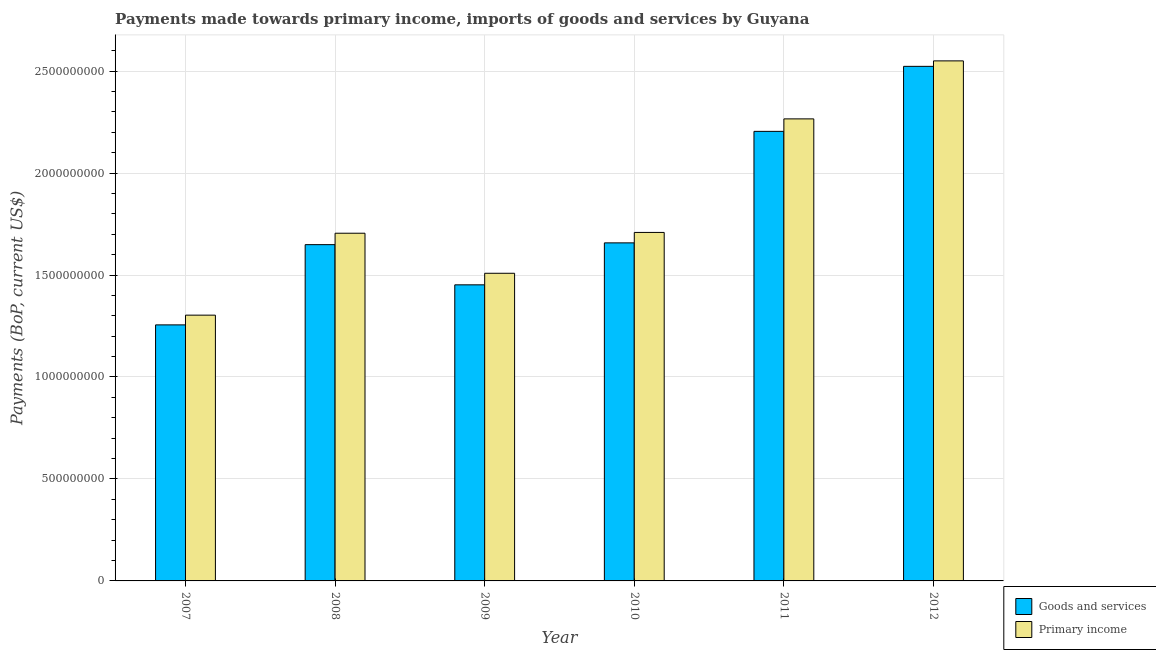How many different coloured bars are there?
Offer a terse response. 2. How many groups of bars are there?
Offer a terse response. 6. Are the number of bars per tick equal to the number of legend labels?
Give a very brief answer. Yes. How many bars are there on the 4th tick from the left?
Provide a succinct answer. 2. What is the label of the 1st group of bars from the left?
Your answer should be very brief. 2007. What is the payments made towards primary income in 2010?
Provide a short and direct response. 1.71e+09. Across all years, what is the maximum payments made towards goods and services?
Offer a very short reply. 2.52e+09. Across all years, what is the minimum payments made towards primary income?
Make the answer very short. 1.30e+09. In which year was the payments made towards goods and services maximum?
Make the answer very short. 2012. In which year was the payments made towards primary income minimum?
Offer a very short reply. 2007. What is the total payments made towards goods and services in the graph?
Provide a short and direct response. 1.07e+1. What is the difference between the payments made towards goods and services in 2007 and that in 2008?
Offer a terse response. -3.93e+08. What is the difference between the payments made towards primary income in 2012 and the payments made towards goods and services in 2010?
Provide a short and direct response. 8.41e+08. What is the average payments made towards goods and services per year?
Provide a short and direct response. 1.79e+09. What is the ratio of the payments made towards goods and services in 2008 to that in 2011?
Your response must be concise. 0.75. Is the difference between the payments made towards primary income in 2007 and 2010 greater than the difference between the payments made towards goods and services in 2007 and 2010?
Provide a short and direct response. No. What is the difference between the highest and the second highest payments made towards primary income?
Your response must be concise. 2.84e+08. What is the difference between the highest and the lowest payments made towards primary income?
Offer a very short reply. 1.25e+09. In how many years, is the payments made towards primary income greater than the average payments made towards primary income taken over all years?
Your answer should be very brief. 2. What does the 2nd bar from the left in 2011 represents?
Provide a short and direct response. Primary income. What does the 2nd bar from the right in 2009 represents?
Ensure brevity in your answer.  Goods and services. How many bars are there?
Your answer should be very brief. 12. Are all the bars in the graph horizontal?
Make the answer very short. No. How many years are there in the graph?
Offer a terse response. 6. Are the values on the major ticks of Y-axis written in scientific E-notation?
Ensure brevity in your answer.  No. How many legend labels are there?
Provide a short and direct response. 2. What is the title of the graph?
Provide a short and direct response. Payments made towards primary income, imports of goods and services by Guyana. Does "Primary completion rate" appear as one of the legend labels in the graph?
Keep it short and to the point. No. What is the label or title of the Y-axis?
Your response must be concise. Payments (BoP, current US$). What is the Payments (BoP, current US$) of Goods and services in 2007?
Offer a very short reply. 1.26e+09. What is the Payments (BoP, current US$) of Primary income in 2007?
Provide a succinct answer. 1.30e+09. What is the Payments (BoP, current US$) of Goods and services in 2008?
Keep it short and to the point. 1.65e+09. What is the Payments (BoP, current US$) in Primary income in 2008?
Ensure brevity in your answer.  1.70e+09. What is the Payments (BoP, current US$) of Goods and services in 2009?
Provide a succinct answer. 1.45e+09. What is the Payments (BoP, current US$) in Primary income in 2009?
Offer a very short reply. 1.51e+09. What is the Payments (BoP, current US$) of Goods and services in 2010?
Offer a terse response. 1.66e+09. What is the Payments (BoP, current US$) in Primary income in 2010?
Keep it short and to the point. 1.71e+09. What is the Payments (BoP, current US$) of Goods and services in 2011?
Your answer should be compact. 2.20e+09. What is the Payments (BoP, current US$) of Primary income in 2011?
Your answer should be compact. 2.27e+09. What is the Payments (BoP, current US$) of Goods and services in 2012?
Your answer should be very brief. 2.52e+09. What is the Payments (BoP, current US$) of Primary income in 2012?
Provide a succinct answer. 2.55e+09. Across all years, what is the maximum Payments (BoP, current US$) in Goods and services?
Your response must be concise. 2.52e+09. Across all years, what is the maximum Payments (BoP, current US$) of Primary income?
Your answer should be compact. 2.55e+09. Across all years, what is the minimum Payments (BoP, current US$) of Goods and services?
Provide a succinct answer. 1.26e+09. Across all years, what is the minimum Payments (BoP, current US$) of Primary income?
Your response must be concise. 1.30e+09. What is the total Payments (BoP, current US$) of Goods and services in the graph?
Provide a short and direct response. 1.07e+1. What is the total Payments (BoP, current US$) of Primary income in the graph?
Your answer should be very brief. 1.10e+1. What is the difference between the Payments (BoP, current US$) in Goods and services in 2007 and that in 2008?
Provide a succinct answer. -3.93e+08. What is the difference between the Payments (BoP, current US$) of Primary income in 2007 and that in 2008?
Keep it short and to the point. -4.02e+08. What is the difference between the Payments (BoP, current US$) in Goods and services in 2007 and that in 2009?
Your answer should be compact. -1.96e+08. What is the difference between the Payments (BoP, current US$) of Primary income in 2007 and that in 2009?
Make the answer very short. -2.05e+08. What is the difference between the Payments (BoP, current US$) of Goods and services in 2007 and that in 2010?
Offer a very short reply. -4.02e+08. What is the difference between the Payments (BoP, current US$) of Primary income in 2007 and that in 2010?
Your answer should be very brief. -4.06e+08. What is the difference between the Payments (BoP, current US$) in Goods and services in 2007 and that in 2011?
Provide a short and direct response. -9.49e+08. What is the difference between the Payments (BoP, current US$) in Primary income in 2007 and that in 2011?
Your answer should be very brief. -9.62e+08. What is the difference between the Payments (BoP, current US$) in Goods and services in 2007 and that in 2012?
Your answer should be compact. -1.27e+09. What is the difference between the Payments (BoP, current US$) in Primary income in 2007 and that in 2012?
Your answer should be compact. -1.25e+09. What is the difference between the Payments (BoP, current US$) of Goods and services in 2008 and that in 2009?
Offer a very short reply. 1.97e+08. What is the difference between the Payments (BoP, current US$) of Primary income in 2008 and that in 2009?
Ensure brevity in your answer.  1.96e+08. What is the difference between the Payments (BoP, current US$) of Goods and services in 2008 and that in 2010?
Offer a very short reply. -8.76e+06. What is the difference between the Payments (BoP, current US$) in Primary income in 2008 and that in 2010?
Provide a short and direct response. -3.92e+06. What is the difference between the Payments (BoP, current US$) in Goods and services in 2008 and that in 2011?
Your response must be concise. -5.55e+08. What is the difference between the Payments (BoP, current US$) in Primary income in 2008 and that in 2011?
Offer a terse response. -5.61e+08. What is the difference between the Payments (BoP, current US$) in Goods and services in 2008 and that in 2012?
Keep it short and to the point. -8.74e+08. What is the difference between the Payments (BoP, current US$) of Primary income in 2008 and that in 2012?
Ensure brevity in your answer.  -8.45e+08. What is the difference between the Payments (BoP, current US$) of Goods and services in 2009 and that in 2010?
Your response must be concise. -2.06e+08. What is the difference between the Payments (BoP, current US$) in Primary income in 2009 and that in 2010?
Offer a very short reply. -2.00e+08. What is the difference between the Payments (BoP, current US$) in Goods and services in 2009 and that in 2011?
Make the answer very short. -7.52e+08. What is the difference between the Payments (BoP, current US$) in Primary income in 2009 and that in 2011?
Offer a terse response. -7.57e+08. What is the difference between the Payments (BoP, current US$) of Goods and services in 2009 and that in 2012?
Offer a terse response. -1.07e+09. What is the difference between the Payments (BoP, current US$) in Primary income in 2009 and that in 2012?
Provide a short and direct response. -1.04e+09. What is the difference between the Payments (BoP, current US$) of Goods and services in 2010 and that in 2011?
Provide a short and direct response. -5.47e+08. What is the difference between the Payments (BoP, current US$) in Primary income in 2010 and that in 2011?
Keep it short and to the point. -5.57e+08. What is the difference between the Payments (BoP, current US$) of Goods and services in 2010 and that in 2012?
Give a very brief answer. -8.66e+08. What is the difference between the Payments (BoP, current US$) of Primary income in 2010 and that in 2012?
Your answer should be very brief. -8.41e+08. What is the difference between the Payments (BoP, current US$) in Goods and services in 2011 and that in 2012?
Offer a very short reply. -3.19e+08. What is the difference between the Payments (BoP, current US$) of Primary income in 2011 and that in 2012?
Give a very brief answer. -2.84e+08. What is the difference between the Payments (BoP, current US$) of Goods and services in 2007 and the Payments (BoP, current US$) of Primary income in 2008?
Your answer should be very brief. -4.49e+08. What is the difference between the Payments (BoP, current US$) in Goods and services in 2007 and the Payments (BoP, current US$) in Primary income in 2009?
Your answer should be very brief. -2.53e+08. What is the difference between the Payments (BoP, current US$) in Goods and services in 2007 and the Payments (BoP, current US$) in Primary income in 2010?
Make the answer very short. -4.53e+08. What is the difference between the Payments (BoP, current US$) in Goods and services in 2007 and the Payments (BoP, current US$) in Primary income in 2011?
Provide a short and direct response. -1.01e+09. What is the difference between the Payments (BoP, current US$) in Goods and services in 2007 and the Payments (BoP, current US$) in Primary income in 2012?
Give a very brief answer. -1.29e+09. What is the difference between the Payments (BoP, current US$) of Goods and services in 2008 and the Payments (BoP, current US$) of Primary income in 2009?
Your response must be concise. 1.40e+08. What is the difference between the Payments (BoP, current US$) of Goods and services in 2008 and the Payments (BoP, current US$) of Primary income in 2010?
Ensure brevity in your answer.  -6.00e+07. What is the difference between the Payments (BoP, current US$) in Goods and services in 2008 and the Payments (BoP, current US$) in Primary income in 2011?
Your answer should be compact. -6.17e+08. What is the difference between the Payments (BoP, current US$) in Goods and services in 2008 and the Payments (BoP, current US$) in Primary income in 2012?
Your answer should be compact. -9.01e+08. What is the difference between the Payments (BoP, current US$) in Goods and services in 2009 and the Payments (BoP, current US$) in Primary income in 2010?
Provide a succinct answer. -2.57e+08. What is the difference between the Payments (BoP, current US$) of Goods and services in 2009 and the Payments (BoP, current US$) of Primary income in 2011?
Give a very brief answer. -8.14e+08. What is the difference between the Payments (BoP, current US$) in Goods and services in 2009 and the Payments (BoP, current US$) in Primary income in 2012?
Ensure brevity in your answer.  -1.10e+09. What is the difference between the Payments (BoP, current US$) of Goods and services in 2010 and the Payments (BoP, current US$) of Primary income in 2011?
Make the answer very short. -6.08e+08. What is the difference between the Payments (BoP, current US$) of Goods and services in 2010 and the Payments (BoP, current US$) of Primary income in 2012?
Offer a very short reply. -8.92e+08. What is the difference between the Payments (BoP, current US$) of Goods and services in 2011 and the Payments (BoP, current US$) of Primary income in 2012?
Provide a short and direct response. -3.46e+08. What is the average Payments (BoP, current US$) in Goods and services per year?
Offer a terse response. 1.79e+09. What is the average Payments (BoP, current US$) in Primary income per year?
Your answer should be very brief. 1.84e+09. In the year 2007, what is the difference between the Payments (BoP, current US$) of Goods and services and Payments (BoP, current US$) of Primary income?
Your answer should be very brief. -4.77e+07. In the year 2008, what is the difference between the Payments (BoP, current US$) of Goods and services and Payments (BoP, current US$) of Primary income?
Offer a terse response. -5.61e+07. In the year 2009, what is the difference between the Payments (BoP, current US$) in Goods and services and Payments (BoP, current US$) in Primary income?
Give a very brief answer. -5.67e+07. In the year 2010, what is the difference between the Payments (BoP, current US$) in Goods and services and Payments (BoP, current US$) in Primary income?
Make the answer very short. -5.12e+07. In the year 2011, what is the difference between the Payments (BoP, current US$) of Goods and services and Payments (BoP, current US$) of Primary income?
Give a very brief answer. -6.12e+07. In the year 2012, what is the difference between the Payments (BoP, current US$) of Goods and services and Payments (BoP, current US$) of Primary income?
Provide a succinct answer. -2.69e+07. What is the ratio of the Payments (BoP, current US$) in Goods and services in 2007 to that in 2008?
Make the answer very short. 0.76. What is the ratio of the Payments (BoP, current US$) in Primary income in 2007 to that in 2008?
Offer a very short reply. 0.76. What is the ratio of the Payments (BoP, current US$) in Goods and services in 2007 to that in 2009?
Provide a succinct answer. 0.86. What is the ratio of the Payments (BoP, current US$) in Primary income in 2007 to that in 2009?
Ensure brevity in your answer.  0.86. What is the ratio of the Payments (BoP, current US$) in Goods and services in 2007 to that in 2010?
Keep it short and to the point. 0.76. What is the ratio of the Payments (BoP, current US$) in Primary income in 2007 to that in 2010?
Offer a terse response. 0.76. What is the ratio of the Payments (BoP, current US$) of Goods and services in 2007 to that in 2011?
Keep it short and to the point. 0.57. What is the ratio of the Payments (BoP, current US$) in Primary income in 2007 to that in 2011?
Your response must be concise. 0.58. What is the ratio of the Payments (BoP, current US$) in Goods and services in 2007 to that in 2012?
Offer a very short reply. 0.5. What is the ratio of the Payments (BoP, current US$) in Primary income in 2007 to that in 2012?
Make the answer very short. 0.51. What is the ratio of the Payments (BoP, current US$) of Goods and services in 2008 to that in 2009?
Keep it short and to the point. 1.14. What is the ratio of the Payments (BoP, current US$) of Primary income in 2008 to that in 2009?
Your answer should be very brief. 1.13. What is the ratio of the Payments (BoP, current US$) of Primary income in 2008 to that in 2010?
Your answer should be very brief. 1. What is the ratio of the Payments (BoP, current US$) in Goods and services in 2008 to that in 2011?
Your answer should be compact. 0.75. What is the ratio of the Payments (BoP, current US$) of Primary income in 2008 to that in 2011?
Make the answer very short. 0.75. What is the ratio of the Payments (BoP, current US$) in Goods and services in 2008 to that in 2012?
Ensure brevity in your answer.  0.65. What is the ratio of the Payments (BoP, current US$) of Primary income in 2008 to that in 2012?
Your response must be concise. 0.67. What is the ratio of the Payments (BoP, current US$) of Goods and services in 2009 to that in 2010?
Your answer should be very brief. 0.88. What is the ratio of the Payments (BoP, current US$) of Primary income in 2009 to that in 2010?
Provide a succinct answer. 0.88. What is the ratio of the Payments (BoP, current US$) in Goods and services in 2009 to that in 2011?
Keep it short and to the point. 0.66. What is the ratio of the Payments (BoP, current US$) in Primary income in 2009 to that in 2011?
Give a very brief answer. 0.67. What is the ratio of the Payments (BoP, current US$) of Goods and services in 2009 to that in 2012?
Keep it short and to the point. 0.58. What is the ratio of the Payments (BoP, current US$) in Primary income in 2009 to that in 2012?
Make the answer very short. 0.59. What is the ratio of the Payments (BoP, current US$) in Goods and services in 2010 to that in 2011?
Provide a succinct answer. 0.75. What is the ratio of the Payments (BoP, current US$) of Primary income in 2010 to that in 2011?
Provide a short and direct response. 0.75. What is the ratio of the Payments (BoP, current US$) in Goods and services in 2010 to that in 2012?
Provide a short and direct response. 0.66. What is the ratio of the Payments (BoP, current US$) in Primary income in 2010 to that in 2012?
Your answer should be compact. 0.67. What is the ratio of the Payments (BoP, current US$) in Goods and services in 2011 to that in 2012?
Offer a terse response. 0.87. What is the ratio of the Payments (BoP, current US$) of Primary income in 2011 to that in 2012?
Your answer should be very brief. 0.89. What is the difference between the highest and the second highest Payments (BoP, current US$) in Goods and services?
Ensure brevity in your answer.  3.19e+08. What is the difference between the highest and the second highest Payments (BoP, current US$) in Primary income?
Offer a terse response. 2.84e+08. What is the difference between the highest and the lowest Payments (BoP, current US$) of Goods and services?
Ensure brevity in your answer.  1.27e+09. What is the difference between the highest and the lowest Payments (BoP, current US$) in Primary income?
Your answer should be very brief. 1.25e+09. 